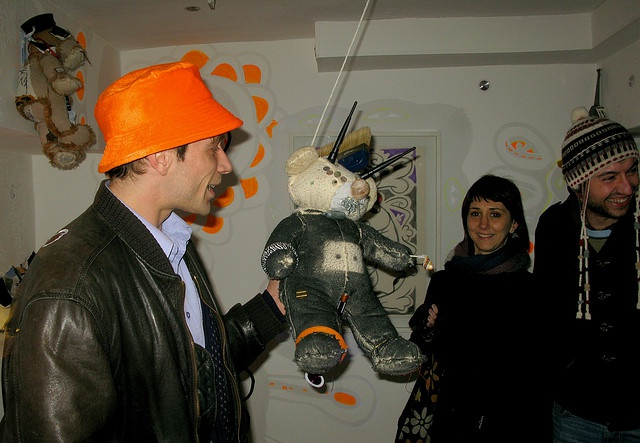Describe the objects in this image and their specific colors. I can see people in gray, black, red, and tan tones, people in gray, black, and maroon tones, teddy bear in gray, black, and tan tones, and people in gray, black, and maroon tones in this image. 